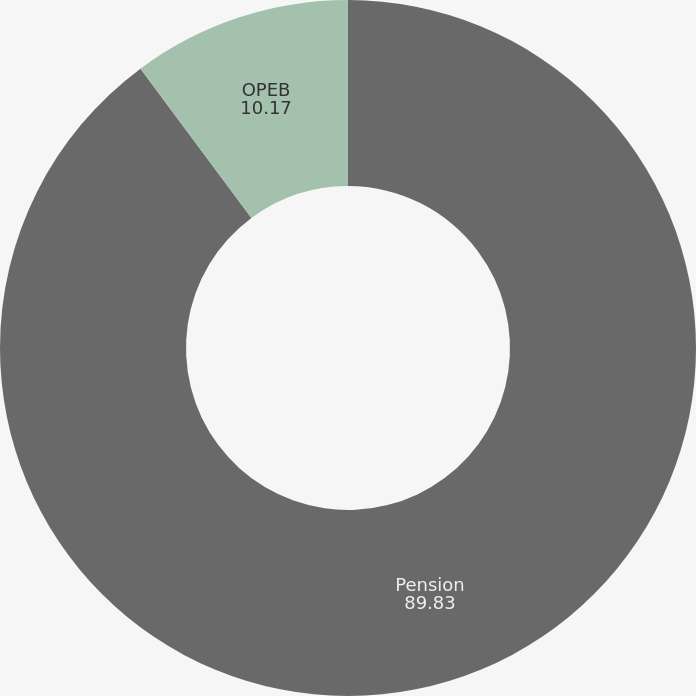Convert chart. <chart><loc_0><loc_0><loc_500><loc_500><pie_chart><fcel>Pension<fcel>OPEB<nl><fcel>89.83%<fcel>10.17%<nl></chart> 